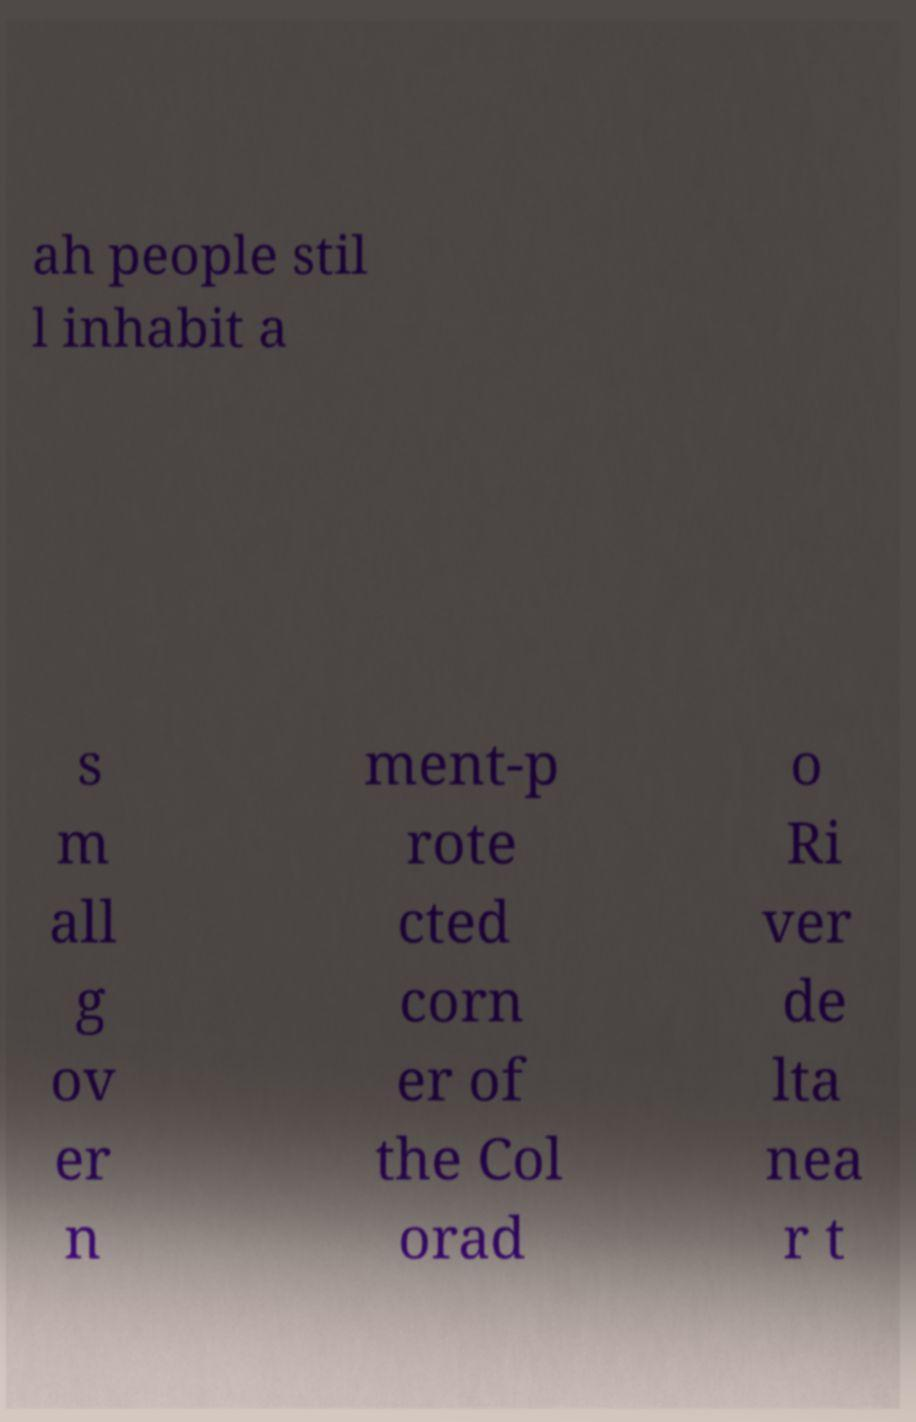There's text embedded in this image that I need extracted. Can you transcribe it verbatim? ah people stil l inhabit a s m all g ov er n ment-p rote cted corn er of the Col orad o Ri ver de lta nea r t 